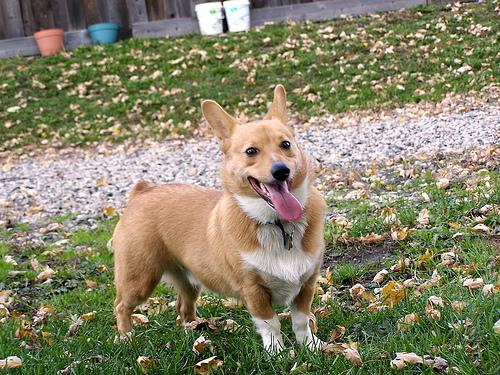What might be a typical day in the life for this dog? A typical day for a spirited Pembroke Welsh Corgi like the one in the image likely includes a blend of playful antics and periods of rest. After a morning greeting filled with excited barks and tail wags, it might spend time exploring the yard, engaging in a mix of sniffing around and brisk runs, showcasing its herding lineage. Playtime could involve a favorite ball or frisbee, followed by a well-deserved nap in a sunny spot. Training sessions to keep its mind sharp are also on the agenda, with rewards of treats for successfully learned commands or tricks. As evening draws near, this social dog would cherish family time, curling up close to its loved ones and, finally, dozing off dreaming of the next day's adventures. 